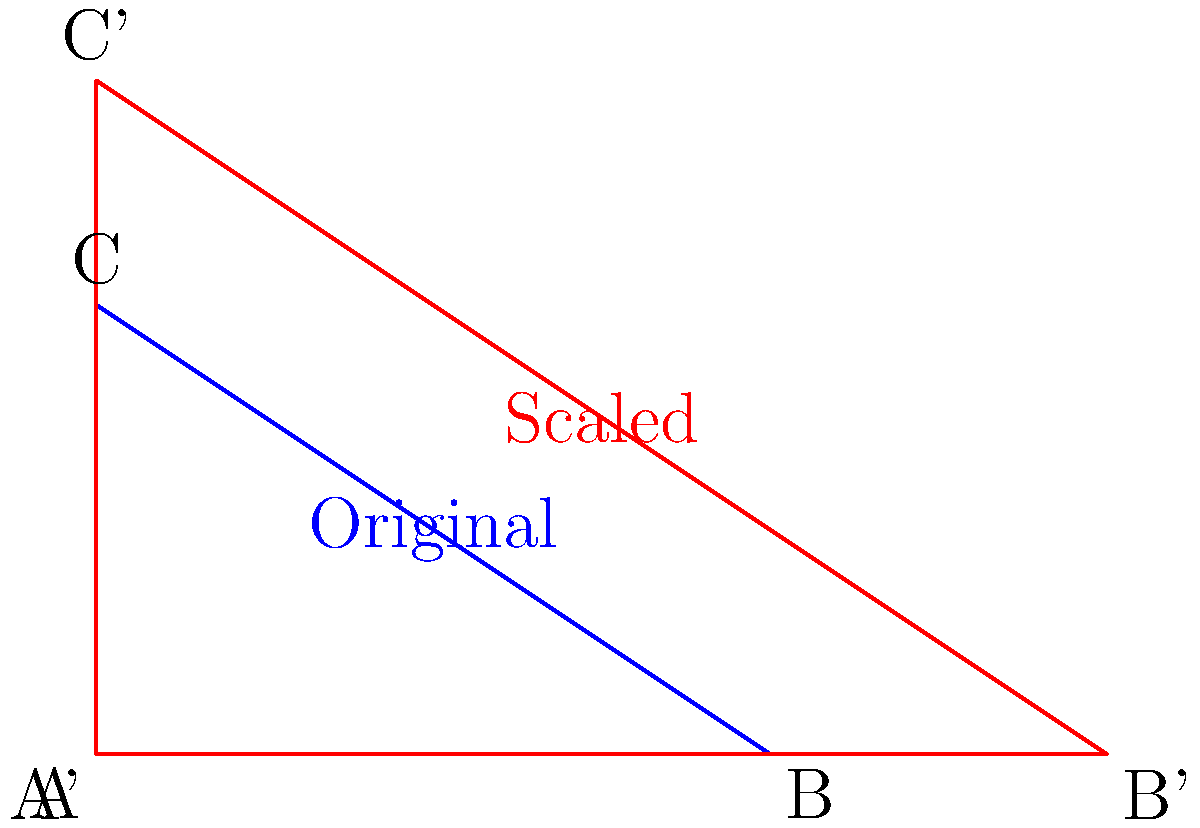As the CEO of a rival language technology company, you're analyzing scaling algorithms for speech recognition patterns. Consider the blue triangle ABC in the diagram, which represents an original speech pattern. If this pattern is scaled by a factor of 1.5 to produce the red triangle A'B'C', how does the area of the scaled triangle compare to the original? Express your answer as a ratio of the scaled area to the original area. Let's approach this step-by-step:

1) The area of a triangle is given by the formula: $A = \frac{1}{2} \times base \times height$

2) When we scale a shape by a factor of k, all linear dimensions are multiplied by k. This means:
   - The new base = k × original base
   - The new height = k × original height

3) In this case, the scale factor k = 1.5

4) The area of the scaled triangle is:
   $A_{new} = \frac{1}{2} \times (1.5 \times base) \times (1.5 \times height)$

5) We can factor this:
   $A_{new} = \frac{1}{2} \times 1.5^2 \times base \times height$

6) Recognize that $\frac{1}{2} \times base \times height$ is the area of the original triangle:
   $A_{new} = 1.5^2 \times A_{original}$

7) Calculate $1.5^2$:
   $A_{new} = 2.25 \times A_{original}$

Therefore, the area of the scaled triangle is 2.25 times the area of the original triangle.
Answer: 2.25:1 